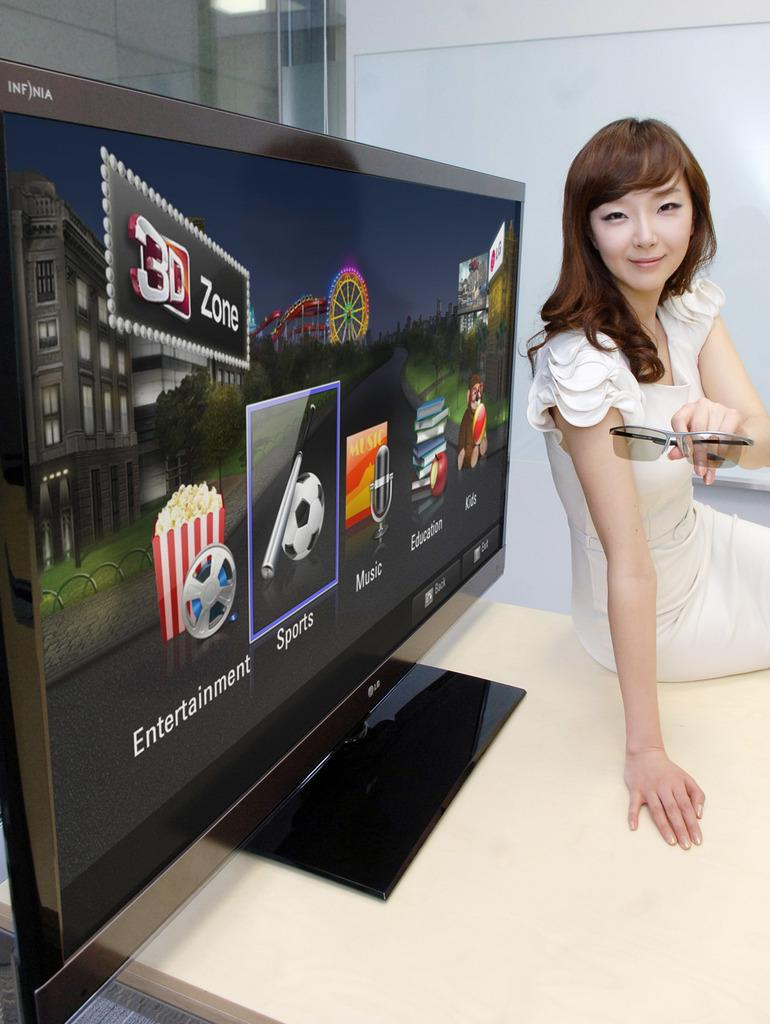<image>
Create a compact narrative representing the image presented. A lady sits by the tv holding a pair of glasses and on the tv it says entertainment and a list of apps. 